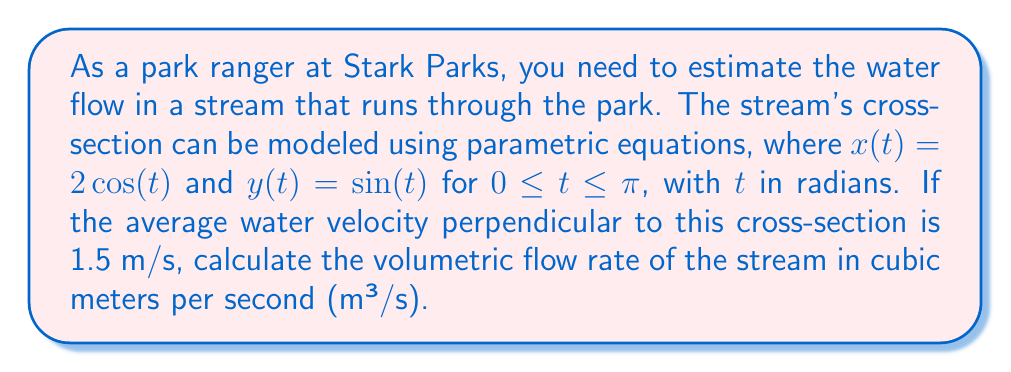Can you answer this question? To solve this problem, we need to follow these steps:

1) The volumetric flow rate is given by the product of the cross-sectional area and the average velocity. We need to calculate the area of the stream's cross-section.

2) The area of a region bounded by parametric equations can be calculated using the formula:

   $$A = \int_{a}^{b} x(t)\frac{dy}{dt}dt$$

3) We have $x(t) = 2\cos(t)$ and $y(t) = \sin(t)$. We need to find $\frac{dy}{dt}$:

   $$\frac{dy}{dt} = \cos(t)$$

4) Substituting into the area formula:

   $$A = \int_{0}^{\pi} 2\cos(t)\cos(t)dt = \int_{0}^{\pi} 2\cos^2(t)dt$$

5) Using the trigonometric identity $\cos^2(t) = \frac{1 + \cos(2t)}{2}$:

   $$A = \int_{0}^{\pi} (1 + \cos(2t))dt = [t + \frac{1}{2}\sin(2t)]_{0}^{\pi} = \pi$$

6) The cross-sectional area is $\pi$ square meters.

7) The volumetric flow rate $Q$ is the product of this area and the average velocity:

   $$Q = A \cdot v = \pi \cdot 1.5 \approx 4.71 \text{ m³/s}$$
Answer: The volumetric flow rate of the stream is approximately 4.71 m³/s. 